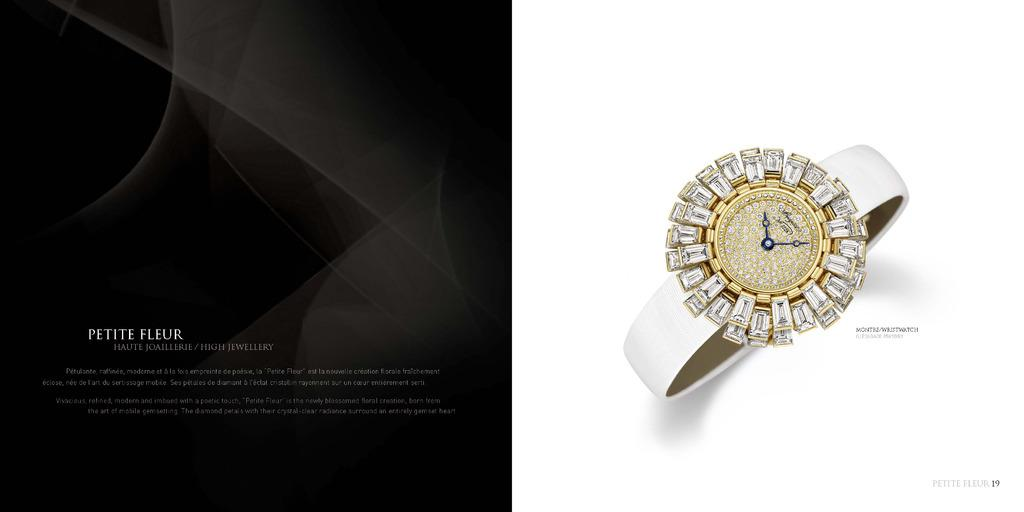<image>
Summarize the visual content of the image. An ad for a watch has the words petite fleur on it. 